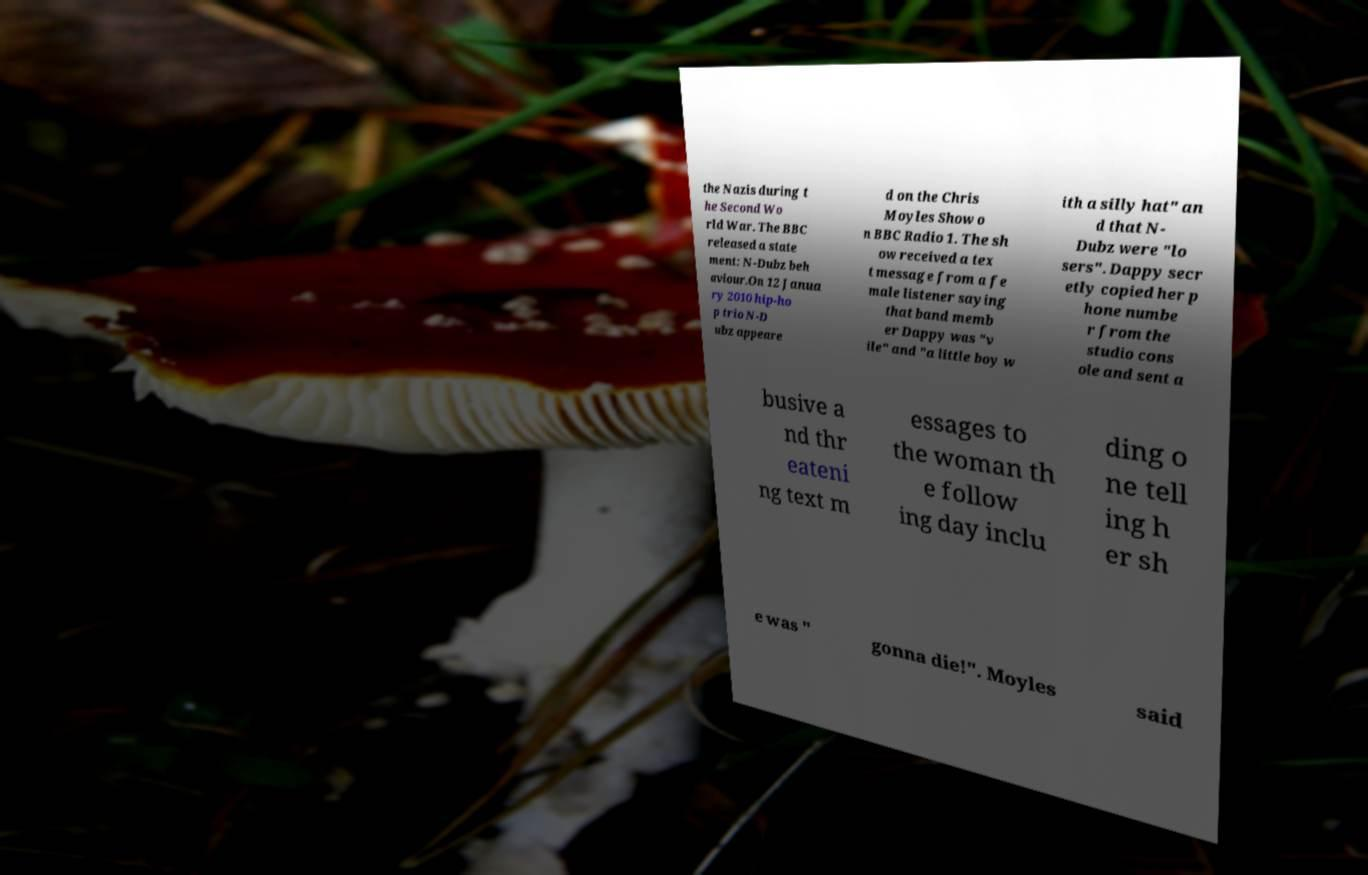I need the written content from this picture converted into text. Can you do that? the Nazis during t he Second Wo rld War. The BBC released a state ment: N-Dubz beh aviour.On 12 Janua ry 2010 hip-ho p trio N-D ubz appeare d on the Chris Moyles Show o n BBC Radio 1. The sh ow received a tex t message from a fe male listener saying that band memb er Dappy was "v ile" and "a little boy w ith a silly hat" an d that N- Dubz were "lo sers". Dappy secr etly copied her p hone numbe r from the studio cons ole and sent a busive a nd thr eateni ng text m essages to the woman th e follow ing day inclu ding o ne tell ing h er sh e was " gonna die!". Moyles said 